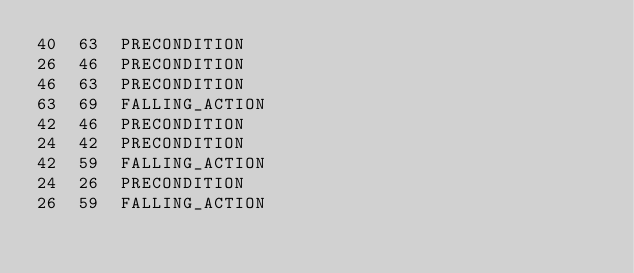Convert code to text. <code><loc_0><loc_0><loc_500><loc_500><_SQL_>40	63	PRECONDITION
26	46	PRECONDITION
46	63	PRECONDITION
63	69	FALLING_ACTION
42	46	PRECONDITION
24	42	PRECONDITION
42	59	FALLING_ACTION
24	26	PRECONDITION
26	59	FALLING_ACTION
</code> 